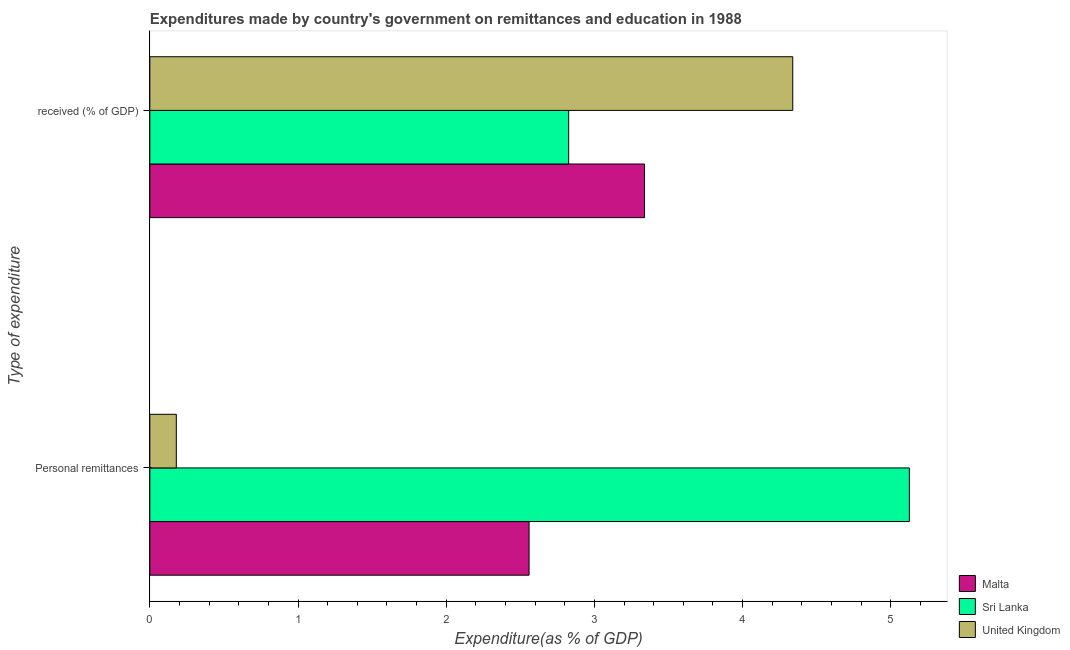How many bars are there on the 2nd tick from the bottom?
Provide a short and direct response. 3. What is the label of the 2nd group of bars from the top?
Ensure brevity in your answer.  Personal remittances. What is the expenditure in education in Sri Lanka?
Provide a succinct answer. 2.83. Across all countries, what is the maximum expenditure in education?
Keep it short and to the point. 4.34. Across all countries, what is the minimum expenditure in personal remittances?
Your answer should be compact. 0.18. In which country was the expenditure in education maximum?
Make the answer very short. United Kingdom. In which country was the expenditure in education minimum?
Offer a terse response. Sri Lanka. What is the total expenditure in personal remittances in the graph?
Your answer should be very brief. 7.86. What is the difference between the expenditure in personal remittances in United Kingdom and that in Sri Lanka?
Your answer should be compact. -4.95. What is the difference between the expenditure in education in Sri Lanka and the expenditure in personal remittances in United Kingdom?
Ensure brevity in your answer.  2.65. What is the average expenditure in education per country?
Give a very brief answer. 3.5. What is the difference between the expenditure in education and expenditure in personal remittances in United Kingdom?
Offer a terse response. 4.16. What is the ratio of the expenditure in personal remittances in Sri Lanka to that in Malta?
Make the answer very short. 2. Is the expenditure in personal remittances in Sri Lanka less than that in Malta?
Give a very brief answer. No. In how many countries, is the expenditure in personal remittances greater than the average expenditure in personal remittances taken over all countries?
Offer a very short reply. 1. What does the 2nd bar from the top in  received (% of GDP) represents?
Keep it short and to the point. Sri Lanka. What does the 2nd bar from the bottom in Personal remittances represents?
Offer a very short reply. Sri Lanka. How many countries are there in the graph?
Your answer should be very brief. 3. What is the difference between two consecutive major ticks on the X-axis?
Make the answer very short. 1. Where does the legend appear in the graph?
Provide a succinct answer. Bottom right. What is the title of the graph?
Keep it short and to the point. Expenditures made by country's government on remittances and education in 1988. Does "East Asia (all income levels)" appear as one of the legend labels in the graph?
Your answer should be very brief. No. What is the label or title of the X-axis?
Give a very brief answer. Expenditure(as % of GDP). What is the label or title of the Y-axis?
Offer a terse response. Type of expenditure. What is the Expenditure(as % of GDP) of Malta in Personal remittances?
Offer a very short reply. 2.56. What is the Expenditure(as % of GDP) in Sri Lanka in Personal remittances?
Your answer should be very brief. 5.13. What is the Expenditure(as % of GDP) of United Kingdom in Personal remittances?
Offer a very short reply. 0.18. What is the Expenditure(as % of GDP) of Malta in  received (% of GDP)?
Give a very brief answer. 3.34. What is the Expenditure(as % of GDP) in Sri Lanka in  received (% of GDP)?
Give a very brief answer. 2.83. What is the Expenditure(as % of GDP) in United Kingdom in  received (% of GDP)?
Give a very brief answer. 4.34. Across all Type of expenditure, what is the maximum Expenditure(as % of GDP) of Malta?
Provide a succinct answer. 3.34. Across all Type of expenditure, what is the maximum Expenditure(as % of GDP) in Sri Lanka?
Provide a succinct answer. 5.13. Across all Type of expenditure, what is the maximum Expenditure(as % of GDP) of United Kingdom?
Offer a very short reply. 4.34. Across all Type of expenditure, what is the minimum Expenditure(as % of GDP) in Malta?
Your answer should be compact. 2.56. Across all Type of expenditure, what is the minimum Expenditure(as % of GDP) in Sri Lanka?
Ensure brevity in your answer.  2.83. Across all Type of expenditure, what is the minimum Expenditure(as % of GDP) of United Kingdom?
Keep it short and to the point. 0.18. What is the total Expenditure(as % of GDP) of Malta in the graph?
Give a very brief answer. 5.9. What is the total Expenditure(as % of GDP) in Sri Lanka in the graph?
Your response must be concise. 7.95. What is the total Expenditure(as % of GDP) of United Kingdom in the graph?
Your response must be concise. 4.52. What is the difference between the Expenditure(as % of GDP) in Malta in Personal remittances and that in  received (% of GDP)?
Your answer should be compact. -0.78. What is the difference between the Expenditure(as % of GDP) in Sri Lanka in Personal remittances and that in  received (% of GDP)?
Offer a very short reply. 2.3. What is the difference between the Expenditure(as % of GDP) of United Kingdom in Personal remittances and that in  received (% of GDP)?
Make the answer very short. -4.16. What is the difference between the Expenditure(as % of GDP) in Malta in Personal remittances and the Expenditure(as % of GDP) in Sri Lanka in  received (% of GDP)?
Give a very brief answer. -0.27. What is the difference between the Expenditure(as % of GDP) in Malta in Personal remittances and the Expenditure(as % of GDP) in United Kingdom in  received (% of GDP)?
Offer a terse response. -1.78. What is the difference between the Expenditure(as % of GDP) of Sri Lanka in Personal remittances and the Expenditure(as % of GDP) of United Kingdom in  received (% of GDP)?
Ensure brevity in your answer.  0.79. What is the average Expenditure(as % of GDP) in Malta per Type of expenditure?
Make the answer very short. 2.95. What is the average Expenditure(as % of GDP) of Sri Lanka per Type of expenditure?
Your response must be concise. 3.98. What is the average Expenditure(as % of GDP) in United Kingdom per Type of expenditure?
Ensure brevity in your answer.  2.26. What is the difference between the Expenditure(as % of GDP) of Malta and Expenditure(as % of GDP) of Sri Lanka in Personal remittances?
Give a very brief answer. -2.57. What is the difference between the Expenditure(as % of GDP) of Malta and Expenditure(as % of GDP) of United Kingdom in Personal remittances?
Offer a very short reply. 2.38. What is the difference between the Expenditure(as % of GDP) in Sri Lanka and Expenditure(as % of GDP) in United Kingdom in Personal remittances?
Ensure brevity in your answer.  4.95. What is the difference between the Expenditure(as % of GDP) of Malta and Expenditure(as % of GDP) of Sri Lanka in  received (% of GDP)?
Your answer should be very brief. 0.51. What is the difference between the Expenditure(as % of GDP) in Malta and Expenditure(as % of GDP) in United Kingdom in  received (% of GDP)?
Give a very brief answer. -1. What is the difference between the Expenditure(as % of GDP) in Sri Lanka and Expenditure(as % of GDP) in United Kingdom in  received (% of GDP)?
Your answer should be very brief. -1.51. What is the ratio of the Expenditure(as % of GDP) in Malta in Personal remittances to that in  received (% of GDP)?
Give a very brief answer. 0.77. What is the ratio of the Expenditure(as % of GDP) of Sri Lanka in Personal remittances to that in  received (% of GDP)?
Ensure brevity in your answer.  1.81. What is the ratio of the Expenditure(as % of GDP) of United Kingdom in Personal remittances to that in  received (% of GDP)?
Give a very brief answer. 0.04. What is the difference between the highest and the second highest Expenditure(as % of GDP) in Malta?
Provide a succinct answer. 0.78. What is the difference between the highest and the second highest Expenditure(as % of GDP) in Sri Lanka?
Provide a short and direct response. 2.3. What is the difference between the highest and the second highest Expenditure(as % of GDP) in United Kingdom?
Your answer should be very brief. 4.16. What is the difference between the highest and the lowest Expenditure(as % of GDP) in Malta?
Offer a very short reply. 0.78. What is the difference between the highest and the lowest Expenditure(as % of GDP) in Sri Lanka?
Offer a terse response. 2.3. What is the difference between the highest and the lowest Expenditure(as % of GDP) in United Kingdom?
Provide a succinct answer. 4.16. 